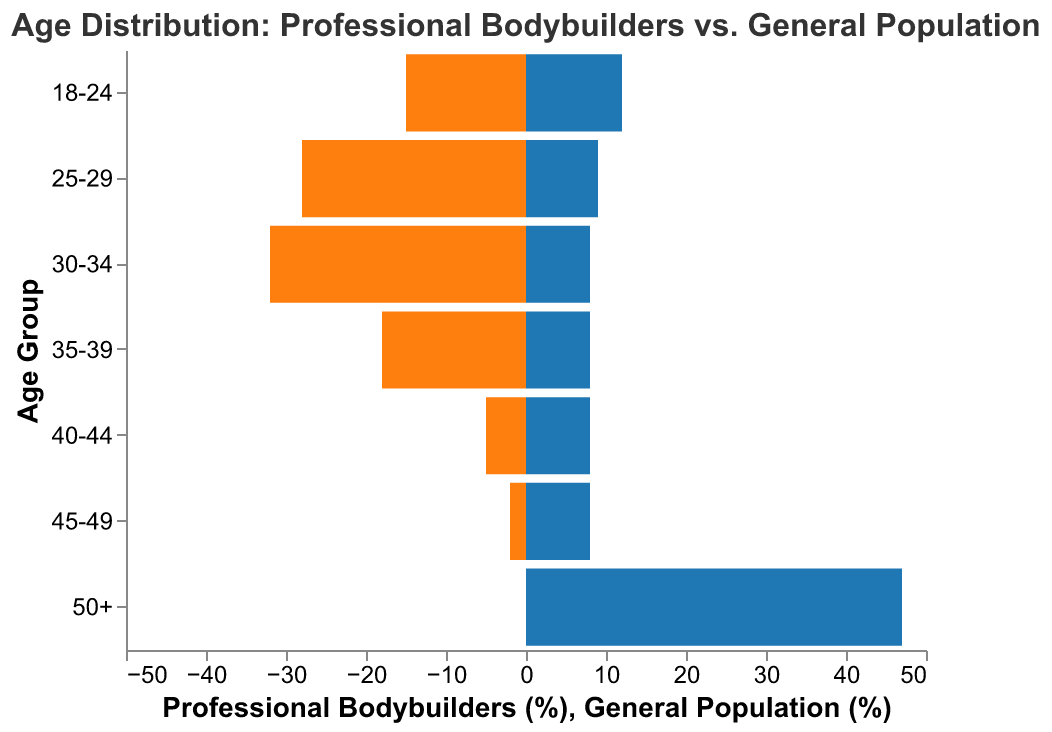What age group has the highest percentage of professional bodybuilders? The highest bar on the left side of the pyramid (for professional bodybuilders) is for the age group 30-34.
Answer: 30-34 What is the difference in percentage between professional bodybuilders and the general population in the 25-29 age group? Looking at the bars for the 25-29 age group, the professional bodybuilders' percentage is 28%, and the general population's percentage is 9%. The difference is 28% - 9% = 19%.
Answer: 19% Which age group has a higher percentage in the general population compared to professional bodybuilders? The age group 50+ has a higher percentage in the general population, with no professional bodybuilders in this group. It is also evident that the age groups 40-44, 45-49, and 50+ have a general population percentage significantly higher than professional bodybuilders.
Answer: 50+ How does the percentage of professional bodybuilders change from the 30-34 to the 35-39 age group? The percentage of professional bodybuilders decreases from 32% in age group 30-34 to 18% in age group 35-39. To find the change, we compute 32% - 18% = 14%.
Answer: Decreases by 14% What can you infer about the peak competitive years for professional bodybuilders? The highest percentages for professional bodybuilders are in the age groups 25-29 (28%) and 30-34 (32%). These age ranges indicate the peak competitive years for professional bodybuilders.
Answer: 25-34 Which age group shows the most significant contrast in percentage between professional bodybuilders and the general population, and what is the contrast? The age group 50+ shows the most significant contrast. There are 0% professional bodybuilders compared to 47% of the general population, making the contrast 47%.
Answer: 50+, 47% In the age group 18-24, is the percentage of professional bodybuilders higher or lower than the general population? The bar for professional bodybuilders in the 18-24 age group is higher at 15%, compared to 12% for the general population.
Answer: Higher What percentage of professional bodybuilders are in the age range 35-44? Adding the percentages of the age groups 35-39 and 40-44 for professional bodybuilders: 18% + 5% = 23%.
Answer: 23% How does the percentage of the general population aged 25-29 compare to the percentage of professional bodybuilders of the same age group? The percentage of professional bodybuilders in the 25-29 age group is 28%, whereas, for the general population, it is 9%. This indicates that the general population has significantly lower representation than professional bodybuilders in this age group.
Answer: Lower What is the total percentage of professional bodybuilders aged 40 and above? Adding the percentages of the age groups 40-44, 45-49, and 50+ for professional bodybuilders: 5% + 2% + 0% = 7%.
Answer: 7% 